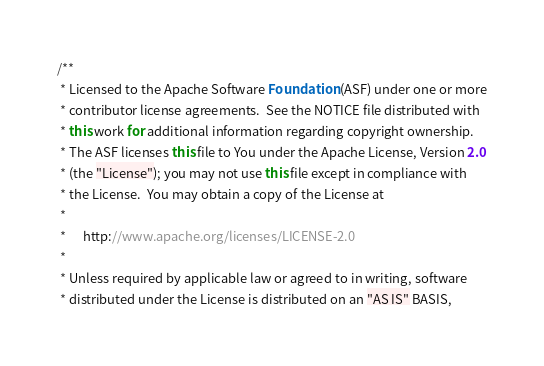Convert code to text. <code><loc_0><loc_0><loc_500><loc_500><_Java_>/**
 * Licensed to the Apache Software Foundation (ASF) under one or more
 * contributor license agreements.  See the NOTICE file distributed with
 * this work for additional information regarding copyright ownership.
 * The ASF licenses this file to You under the Apache License, Version 2.0
 * (the "License"); you may not use this file except in compliance with
 * the License.  You may obtain a copy of the License at
 *
 *      http://www.apache.org/licenses/LICENSE-2.0
 *
 * Unless required by applicable law or agreed to in writing, software
 * distributed under the License is distributed on an "AS IS" BASIS,</code> 